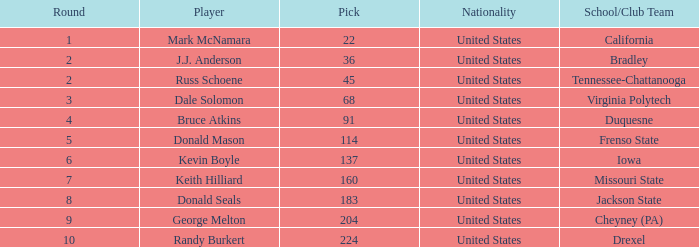What is the nationality of the player from Drexel who had a pick larger than 183? United States. 